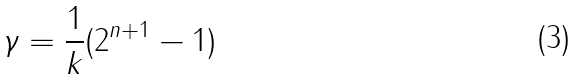Convert formula to latex. <formula><loc_0><loc_0><loc_500><loc_500>\gamma = { \frac { 1 } { k } } ( 2 ^ { n + 1 } - 1 )</formula> 